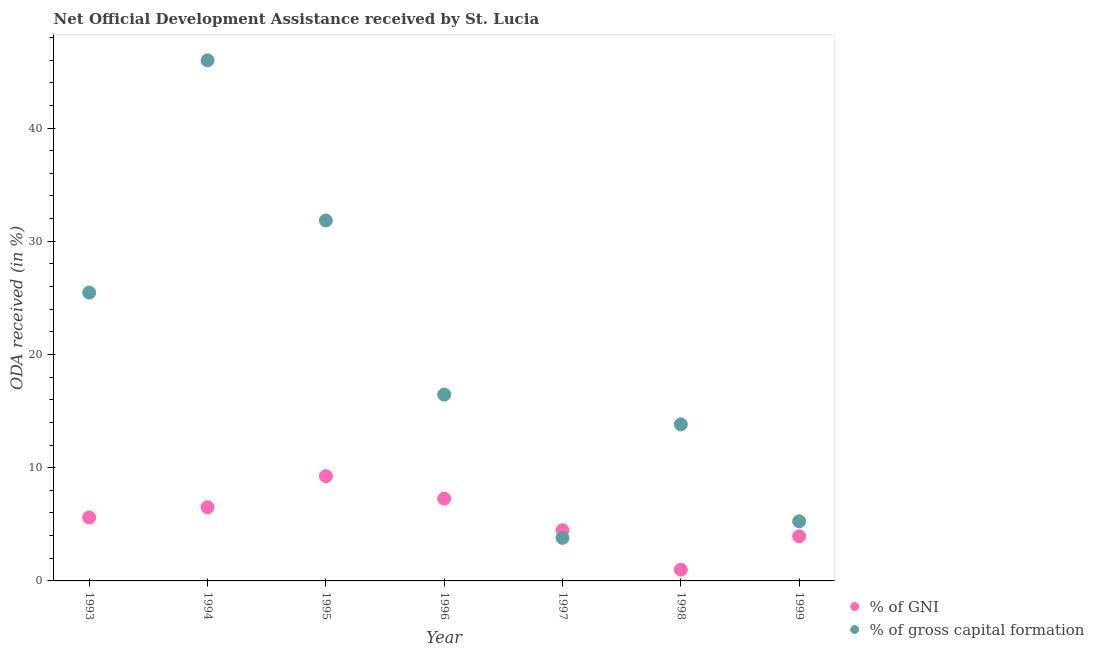What is the oda received as percentage of gross capital formation in 1993?
Make the answer very short. 25.47. Across all years, what is the maximum oda received as percentage of gross capital formation?
Give a very brief answer. 45.98. Across all years, what is the minimum oda received as percentage of gross capital formation?
Ensure brevity in your answer.  3.8. In which year was the oda received as percentage of gross capital formation maximum?
Provide a succinct answer. 1994. What is the total oda received as percentage of gross capital formation in the graph?
Ensure brevity in your answer.  142.64. What is the difference between the oda received as percentage of gni in 1993 and that in 1995?
Offer a terse response. -3.64. What is the difference between the oda received as percentage of gni in 1994 and the oda received as percentage of gross capital formation in 1993?
Provide a succinct answer. -18.96. What is the average oda received as percentage of gross capital formation per year?
Give a very brief answer. 20.38. In the year 1997, what is the difference between the oda received as percentage of gni and oda received as percentage of gross capital formation?
Keep it short and to the point. 0.68. What is the ratio of the oda received as percentage of gross capital formation in 1994 to that in 1996?
Your response must be concise. 2.79. What is the difference between the highest and the second highest oda received as percentage of gross capital formation?
Keep it short and to the point. 14.14. What is the difference between the highest and the lowest oda received as percentage of gni?
Provide a succinct answer. 8.26. Does the oda received as percentage of gni monotonically increase over the years?
Make the answer very short. No. Is the oda received as percentage of gross capital formation strictly greater than the oda received as percentage of gni over the years?
Provide a short and direct response. No. Is the oda received as percentage of gni strictly less than the oda received as percentage of gross capital formation over the years?
Provide a succinct answer. No. How many years are there in the graph?
Keep it short and to the point. 7. Are the values on the major ticks of Y-axis written in scientific E-notation?
Keep it short and to the point. No. Does the graph contain grids?
Keep it short and to the point. No. How many legend labels are there?
Your answer should be compact. 2. How are the legend labels stacked?
Your answer should be very brief. Vertical. What is the title of the graph?
Your response must be concise. Net Official Development Assistance received by St. Lucia. What is the label or title of the Y-axis?
Give a very brief answer. ODA received (in %). What is the ODA received (in %) in % of GNI in 1993?
Ensure brevity in your answer.  5.61. What is the ODA received (in %) in % of gross capital formation in 1993?
Your answer should be compact. 25.47. What is the ODA received (in %) of % of GNI in 1994?
Your response must be concise. 6.51. What is the ODA received (in %) of % of gross capital formation in 1994?
Provide a succinct answer. 45.98. What is the ODA received (in %) of % of GNI in 1995?
Offer a very short reply. 9.25. What is the ODA received (in %) in % of gross capital formation in 1995?
Make the answer very short. 31.84. What is the ODA received (in %) of % of GNI in 1996?
Your answer should be compact. 7.27. What is the ODA received (in %) of % of gross capital formation in 1996?
Keep it short and to the point. 16.46. What is the ODA received (in %) of % of GNI in 1997?
Your answer should be very brief. 4.48. What is the ODA received (in %) of % of gross capital formation in 1997?
Your answer should be very brief. 3.8. What is the ODA received (in %) in % of GNI in 1998?
Keep it short and to the point. 0.99. What is the ODA received (in %) of % of gross capital formation in 1998?
Offer a very short reply. 13.83. What is the ODA received (in %) of % of GNI in 1999?
Your answer should be very brief. 3.94. What is the ODA received (in %) of % of gross capital formation in 1999?
Provide a short and direct response. 5.27. Across all years, what is the maximum ODA received (in %) of % of GNI?
Give a very brief answer. 9.25. Across all years, what is the maximum ODA received (in %) of % of gross capital formation?
Provide a short and direct response. 45.98. Across all years, what is the minimum ODA received (in %) in % of GNI?
Ensure brevity in your answer.  0.99. Across all years, what is the minimum ODA received (in %) in % of gross capital formation?
Your answer should be compact. 3.8. What is the total ODA received (in %) in % of GNI in the graph?
Provide a short and direct response. 38.05. What is the total ODA received (in %) in % of gross capital formation in the graph?
Ensure brevity in your answer.  142.64. What is the difference between the ODA received (in %) of % of GNI in 1993 and that in 1994?
Give a very brief answer. -0.9. What is the difference between the ODA received (in %) of % of gross capital formation in 1993 and that in 1994?
Your answer should be compact. -20.51. What is the difference between the ODA received (in %) of % of GNI in 1993 and that in 1995?
Your response must be concise. -3.64. What is the difference between the ODA received (in %) of % of gross capital formation in 1993 and that in 1995?
Keep it short and to the point. -6.37. What is the difference between the ODA received (in %) of % of GNI in 1993 and that in 1996?
Provide a succinct answer. -1.67. What is the difference between the ODA received (in %) in % of gross capital formation in 1993 and that in 1996?
Make the answer very short. 9.01. What is the difference between the ODA received (in %) of % of GNI in 1993 and that in 1997?
Give a very brief answer. 1.13. What is the difference between the ODA received (in %) of % of gross capital formation in 1993 and that in 1997?
Provide a succinct answer. 21.66. What is the difference between the ODA received (in %) in % of GNI in 1993 and that in 1998?
Offer a terse response. 4.62. What is the difference between the ODA received (in %) in % of gross capital formation in 1993 and that in 1998?
Your answer should be very brief. 11.64. What is the difference between the ODA received (in %) of % of GNI in 1993 and that in 1999?
Provide a succinct answer. 1.67. What is the difference between the ODA received (in %) of % of gross capital formation in 1993 and that in 1999?
Provide a short and direct response. 20.2. What is the difference between the ODA received (in %) in % of GNI in 1994 and that in 1995?
Offer a terse response. -2.74. What is the difference between the ODA received (in %) in % of gross capital formation in 1994 and that in 1995?
Offer a terse response. 14.14. What is the difference between the ODA received (in %) of % of GNI in 1994 and that in 1996?
Your response must be concise. -0.77. What is the difference between the ODA received (in %) of % of gross capital formation in 1994 and that in 1996?
Give a very brief answer. 29.52. What is the difference between the ODA received (in %) of % of GNI in 1994 and that in 1997?
Keep it short and to the point. 2.03. What is the difference between the ODA received (in %) of % of gross capital formation in 1994 and that in 1997?
Ensure brevity in your answer.  42.18. What is the difference between the ODA received (in %) in % of GNI in 1994 and that in 1998?
Make the answer very short. 5.52. What is the difference between the ODA received (in %) in % of gross capital formation in 1994 and that in 1998?
Offer a terse response. 32.15. What is the difference between the ODA received (in %) in % of GNI in 1994 and that in 1999?
Make the answer very short. 2.57. What is the difference between the ODA received (in %) in % of gross capital formation in 1994 and that in 1999?
Your answer should be compact. 40.71. What is the difference between the ODA received (in %) in % of GNI in 1995 and that in 1996?
Your response must be concise. 1.98. What is the difference between the ODA received (in %) in % of gross capital formation in 1995 and that in 1996?
Provide a short and direct response. 15.38. What is the difference between the ODA received (in %) in % of GNI in 1995 and that in 1997?
Your answer should be compact. 4.77. What is the difference between the ODA received (in %) of % of gross capital formation in 1995 and that in 1997?
Provide a short and direct response. 28.03. What is the difference between the ODA received (in %) in % of GNI in 1995 and that in 1998?
Offer a very short reply. 8.26. What is the difference between the ODA received (in %) of % of gross capital formation in 1995 and that in 1998?
Provide a short and direct response. 18.01. What is the difference between the ODA received (in %) in % of GNI in 1995 and that in 1999?
Keep it short and to the point. 5.31. What is the difference between the ODA received (in %) in % of gross capital formation in 1995 and that in 1999?
Provide a succinct answer. 26.57. What is the difference between the ODA received (in %) in % of GNI in 1996 and that in 1997?
Ensure brevity in your answer.  2.79. What is the difference between the ODA received (in %) in % of gross capital formation in 1996 and that in 1997?
Offer a very short reply. 12.65. What is the difference between the ODA received (in %) of % of GNI in 1996 and that in 1998?
Offer a terse response. 6.28. What is the difference between the ODA received (in %) of % of gross capital formation in 1996 and that in 1998?
Make the answer very short. 2.63. What is the difference between the ODA received (in %) in % of GNI in 1996 and that in 1999?
Make the answer very short. 3.33. What is the difference between the ODA received (in %) in % of gross capital formation in 1996 and that in 1999?
Your answer should be very brief. 11.19. What is the difference between the ODA received (in %) of % of GNI in 1997 and that in 1998?
Your answer should be very brief. 3.49. What is the difference between the ODA received (in %) in % of gross capital formation in 1997 and that in 1998?
Your answer should be compact. -10.02. What is the difference between the ODA received (in %) of % of GNI in 1997 and that in 1999?
Keep it short and to the point. 0.54. What is the difference between the ODA received (in %) in % of gross capital formation in 1997 and that in 1999?
Keep it short and to the point. -1.46. What is the difference between the ODA received (in %) of % of GNI in 1998 and that in 1999?
Offer a terse response. -2.95. What is the difference between the ODA received (in %) of % of gross capital formation in 1998 and that in 1999?
Your answer should be very brief. 8.56. What is the difference between the ODA received (in %) of % of GNI in 1993 and the ODA received (in %) of % of gross capital formation in 1994?
Offer a terse response. -40.37. What is the difference between the ODA received (in %) of % of GNI in 1993 and the ODA received (in %) of % of gross capital formation in 1995?
Provide a succinct answer. -26.23. What is the difference between the ODA received (in %) of % of GNI in 1993 and the ODA received (in %) of % of gross capital formation in 1996?
Your answer should be very brief. -10.85. What is the difference between the ODA received (in %) in % of GNI in 1993 and the ODA received (in %) in % of gross capital formation in 1997?
Your answer should be compact. 1.8. What is the difference between the ODA received (in %) in % of GNI in 1993 and the ODA received (in %) in % of gross capital formation in 1998?
Your response must be concise. -8.22. What is the difference between the ODA received (in %) of % of GNI in 1993 and the ODA received (in %) of % of gross capital formation in 1999?
Offer a terse response. 0.34. What is the difference between the ODA received (in %) of % of GNI in 1994 and the ODA received (in %) of % of gross capital formation in 1995?
Make the answer very short. -25.33. What is the difference between the ODA received (in %) of % of GNI in 1994 and the ODA received (in %) of % of gross capital formation in 1996?
Keep it short and to the point. -9.95. What is the difference between the ODA received (in %) of % of GNI in 1994 and the ODA received (in %) of % of gross capital formation in 1997?
Make the answer very short. 2.71. What is the difference between the ODA received (in %) of % of GNI in 1994 and the ODA received (in %) of % of gross capital formation in 1998?
Give a very brief answer. -7.32. What is the difference between the ODA received (in %) in % of GNI in 1994 and the ODA received (in %) in % of gross capital formation in 1999?
Provide a succinct answer. 1.24. What is the difference between the ODA received (in %) of % of GNI in 1995 and the ODA received (in %) of % of gross capital formation in 1996?
Keep it short and to the point. -7.21. What is the difference between the ODA received (in %) in % of GNI in 1995 and the ODA received (in %) in % of gross capital formation in 1997?
Ensure brevity in your answer.  5.45. What is the difference between the ODA received (in %) in % of GNI in 1995 and the ODA received (in %) in % of gross capital formation in 1998?
Ensure brevity in your answer.  -4.58. What is the difference between the ODA received (in %) of % of GNI in 1995 and the ODA received (in %) of % of gross capital formation in 1999?
Ensure brevity in your answer.  3.98. What is the difference between the ODA received (in %) of % of GNI in 1996 and the ODA received (in %) of % of gross capital formation in 1997?
Your response must be concise. 3.47. What is the difference between the ODA received (in %) in % of GNI in 1996 and the ODA received (in %) in % of gross capital formation in 1998?
Your answer should be compact. -6.55. What is the difference between the ODA received (in %) in % of GNI in 1996 and the ODA received (in %) in % of gross capital formation in 1999?
Offer a very short reply. 2.01. What is the difference between the ODA received (in %) of % of GNI in 1997 and the ODA received (in %) of % of gross capital formation in 1998?
Your answer should be very brief. -9.35. What is the difference between the ODA received (in %) of % of GNI in 1997 and the ODA received (in %) of % of gross capital formation in 1999?
Your answer should be compact. -0.79. What is the difference between the ODA received (in %) in % of GNI in 1998 and the ODA received (in %) in % of gross capital formation in 1999?
Offer a terse response. -4.28. What is the average ODA received (in %) in % of GNI per year?
Your response must be concise. 5.44. What is the average ODA received (in %) in % of gross capital formation per year?
Give a very brief answer. 20.38. In the year 1993, what is the difference between the ODA received (in %) of % of GNI and ODA received (in %) of % of gross capital formation?
Provide a short and direct response. -19.86. In the year 1994, what is the difference between the ODA received (in %) of % of GNI and ODA received (in %) of % of gross capital formation?
Your response must be concise. -39.47. In the year 1995, what is the difference between the ODA received (in %) in % of GNI and ODA received (in %) in % of gross capital formation?
Offer a very short reply. -22.58. In the year 1996, what is the difference between the ODA received (in %) in % of GNI and ODA received (in %) in % of gross capital formation?
Ensure brevity in your answer.  -9.18. In the year 1997, what is the difference between the ODA received (in %) in % of GNI and ODA received (in %) in % of gross capital formation?
Your answer should be very brief. 0.68. In the year 1998, what is the difference between the ODA received (in %) of % of GNI and ODA received (in %) of % of gross capital formation?
Make the answer very short. -12.84. In the year 1999, what is the difference between the ODA received (in %) in % of GNI and ODA received (in %) in % of gross capital formation?
Your answer should be compact. -1.33. What is the ratio of the ODA received (in %) in % of GNI in 1993 to that in 1994?
Your response must be concise. 0.86. What is the ratio of the ODA received (in %) in % of gross capital formation in 1993 to that in 1994?
Provide a short and direct response. 0.55. What is the ratio of the ODA received (in %) in % of GNI in 1993 to that in 1995?
Ensure brevity in your answer.  0.61. What is the ratio of the ODA received (in %) in % of gross capital formation in 1993 to that in 1995?
Provide a short and direct response. 0.8. What is the ratio of the ODA received (in %) in % of GNI in 1993 to that in 1996?
Ensure brevity in your answer.  0.77. What is the ratio of the ODA received (in %) of % of gross capital formation in 1993 to that in 1996?
Offer a terse response. 1.55. What is the ratio of the ODA received (in %) in % of GNI in 1993 to that in 1997?
Your answer should be compact. 1.25. What is the ratio of the ODA received (in %) in % of gross capital formation in 1993 to that in 1997?
Provide a short and direct response. 6.7. What is the ratio of the ODA received (in %) of % of GNI in 1993 to that in 1998?
Give a very brief answer. 5.65. What is the ratio of the ODA received (in %) in % of gross capital formation in 1993 to that in 1998?
Make the answer very short. 1.84. What is the ratio of the ODA received (in %) of % of GNI in 1993 to that in 1999?
Provide a succinct answer. 1.42. What is the ratio of the ODA received (in %) of % of gross capital formation in 1993 to that in 1999?
Ensure brevity in your answer.  4.83. What is the ratio of the ODA received (in %) in % of GNI in 1994 to that in 1995?
Offer a very short reply. 0.7. What is the ratio of the ODA received (in %) in % of gross capital formation in 1994 to that in 1995?
Your answer should be compact. 1.44. What is the ratio of the ODA received (in %) of % of GNI in 1994 to that in 1996?
Offer a terse response. 0.89. What is the ratio of the ODA received (in %) in % of gross capital formation in 1994 to that in 1996?
Your answer should be very brief. 2.79. What is the ratio of the ODA received (in %) in % of GNI in 1994 to that in 1997?
Provide a succinct answer. 1.45. What is the ratio of the ODA received (in %) in % of gross capital formation in 1994 to that in 1997?
Your response must be concise. 12.09. What is the ratio of the ODA received (in %) in % of GNI in 1994 to that in 1998?
Provide a succinct answer. 6.56. What is the ratio of the ODA received (in %) in % of gross capital formation in 1994 to that in 1998?
Give a very brief answer. 3.33. What is the ratio of the ODA received (in %) of % of GNI in 1994 to that in 1999?
Offer a very short reply. 1.65. What is the ratio of the ODA received (in %) of % of gross capital formation in 1994 to that in 1999?
Your response must be concise. 8.73. What is the ratio of the ODA received (in %) in % of GNI in 1995 to that in 1996?
Offer a terse response. 1.27. What is the ratio of the ODA received (in %) of % of gross capital formation in 1995 to that in 1996?
Offer a terse response. 1.93. What is the ratio of the ODA received (in %) in % of GNI in 1995 to that in 1997?
Your response must be concise. 2.07. What is the ratio of the ODA received (in %) in % of gross capital formation in 1995 to that in 1997?
Provide a short and direct response. 8.37. What is the ratio of the ODA received (in %) in % of GNI in 1995 to that in 1998?
Your answer should be very brief. 9.33. What is the ratio of the ODA received (in %) of % of gross capital formation in 1995 to that in 1998?
Make the answer very short. 2.3. What is the ratio of the ODA received (in %) of % of GNI in 1995 to that in 1999?
Offer a terse response. 2.35. What is the ratio of the ODA received (in %) in % of gross capital formation in 1995 to that in 1999?
Your answer should be compact. 6.04. What is the ratio of the ODA received (in %) of % of GNI in 1996 to that in 1997?
Make the answer very short. 1.62. What is the ratio of the ODA received (in %) in % of gross capital formation in 1996 to that in 1997?
Keep it short and to the point. 4.33. What is the ratio of the ODA received (in %) of % of GNI in 1996 to that in 1998?
Provide a short and direct response. 7.34. What is the ratio of the ODA received (in %) of % of gross capital formation in 1996 to that in 1998?
Keep it short and to the point. 1.19. What is the ratio of the ODA received (in %) of % of GNI in 1996 to that in 1999?
Your answer should be very brief. 1.85. What is the ratio of the ODA received (in %) of % of gross capital formation in 1996 to that in 1999?
Your answer should be very brief. 3.12. What is the ratio of the ODA received (in %) of % of GNI in 1997 to that in 1998?
Give a very brief answer. 4.52. What is the ratio of the ODA received (in %) of % of gross capital formation in 1997 to that in 1998?
Provide a succinct answer. 0.28. What is the ratio of the ODA received (in %) in % of GNI in 1997 to that in 1999?
Your answer should be very brief. 1.14. What is the ratio of the ODA received (in %) of % of gross capital formation in 1997 to that in 1999?
Provide a short and direct response. 0.72. What is the ratio of the ODA received (in %) of % of GNI in 1998 to that in 1999?
Provide a short and direct response. 0.25. What is the ratio of the ODA received (in %) of % of gross capital formation in 1998 to that in 1999?
Offer a terse response. 2.63. What is the difference between the highest and the second highest ODA received (in %) in % of GNI?
Provide a short and direct response. 1.98. What is the difference between the highest and the second highest ODA received (in %) of % of gross capital formation?
Make the answer very short. 14.14. What is the difference between the highest and the lowest ODA received (in %) in % of GNI?
Your answer should be compact. 8.26. What is the difference between the highest and the lowest ODA received (in %) of % of gross capital formation?
Make the answer very short. 42.18. 